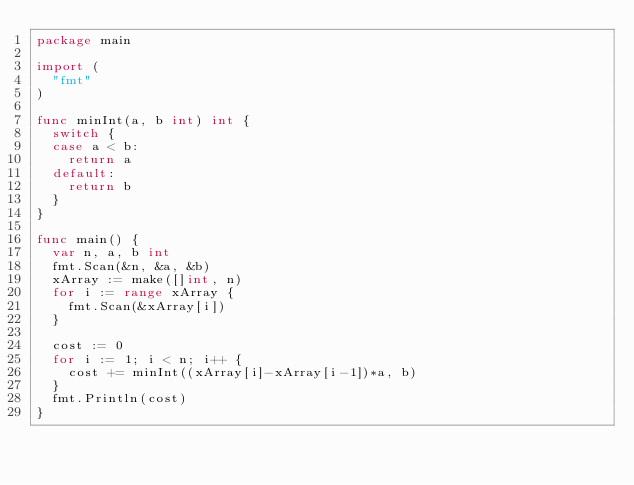<code> <loc_0><loc_0><loc_500><loc_500><_Go_>package main

import (
	"fmt"
)

func minInt(a, b int) int {
	switch {
	case a < b:
		return a
	default:
		return b
	}
}

func main() {
	var n, a, b int
	fmt.Scan(&n, &a, &b)
	xArray := make([]int, n)
	for i := range xArray {
		fmt.Scan(&xArray[i])
	}

	cost := 0
	for i := 1; i < n; i++ {
		cost += minInt((xArray[i]-xArray[i-1])*a, b)
	}
	fmt.Println(cost)
}
</code> 